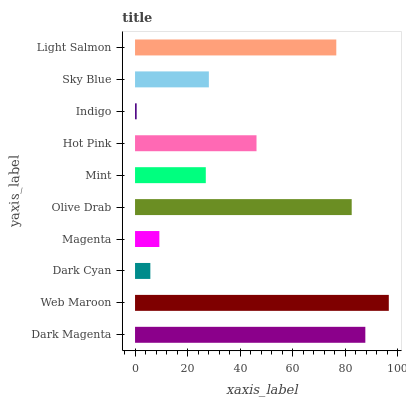Is Indigo the minimum?
Answer yes or no. Yes. Is Web Maroon the maximum?
Answer yes or no. Yes. Is Dark Cyan the minimum?
Answer yes or no. No. Is Dark Cyan the maximum?
Answer yes or no. No. Is Web Maroon greater than Dark Cyan?
Answer yes or no. Yes. Is Dark Cyan less than Web Maroon?
Answer yes or no. Yes. Is Dark Cyan greater than Web Maroon?
Answer yes or no. No. Is Web Maroon less than Dark Cyan?
Answer yes or no. No. Is Hot Pink the high median?
Answer yes or no. Yes. Is Sky Blue the low median?
Answer yes or no. Yes. Is Dark Cyan the high median?
Answer yes or no. No. Is Hot Pink the low median?
Answer yes or no. No. 